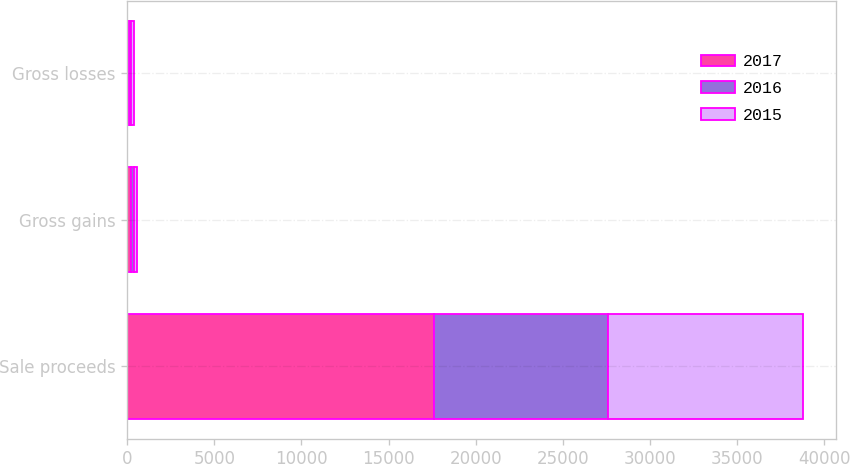Convert chart. <chart><loc_0><loc_0><loc_500><loc_500><stacked_bar_chart><ecel><fcel>Sale proceeds<fcel>Gross gains<fcel>Gross losses<nl><fcel>2017<fcel>17614<fcel>204<fcel>90<nl><fcel>2016<fcel>9984<fcel>196<fcel>138<nl><fcel>2015<fcel>11161<fcel>177<fcel>156<nl></chart> 